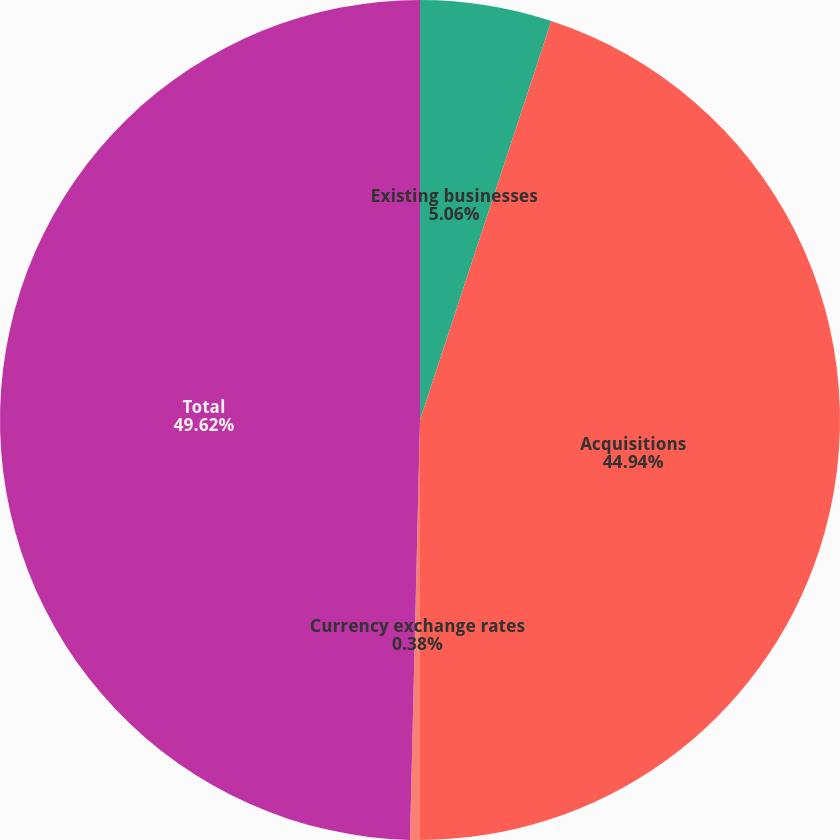Convert chart to OTSL. <chart><loc_0><loc_0><loc_500><loc_500><pie_chart><fcel>Existing businesses<fcel>Acquisitions<fcel>Currency exchange rates<fcel>Total<nl><fcel>5.06%<fcel>44.94%<fcel>0.38%<fcel>49.62%<nl></chart> 